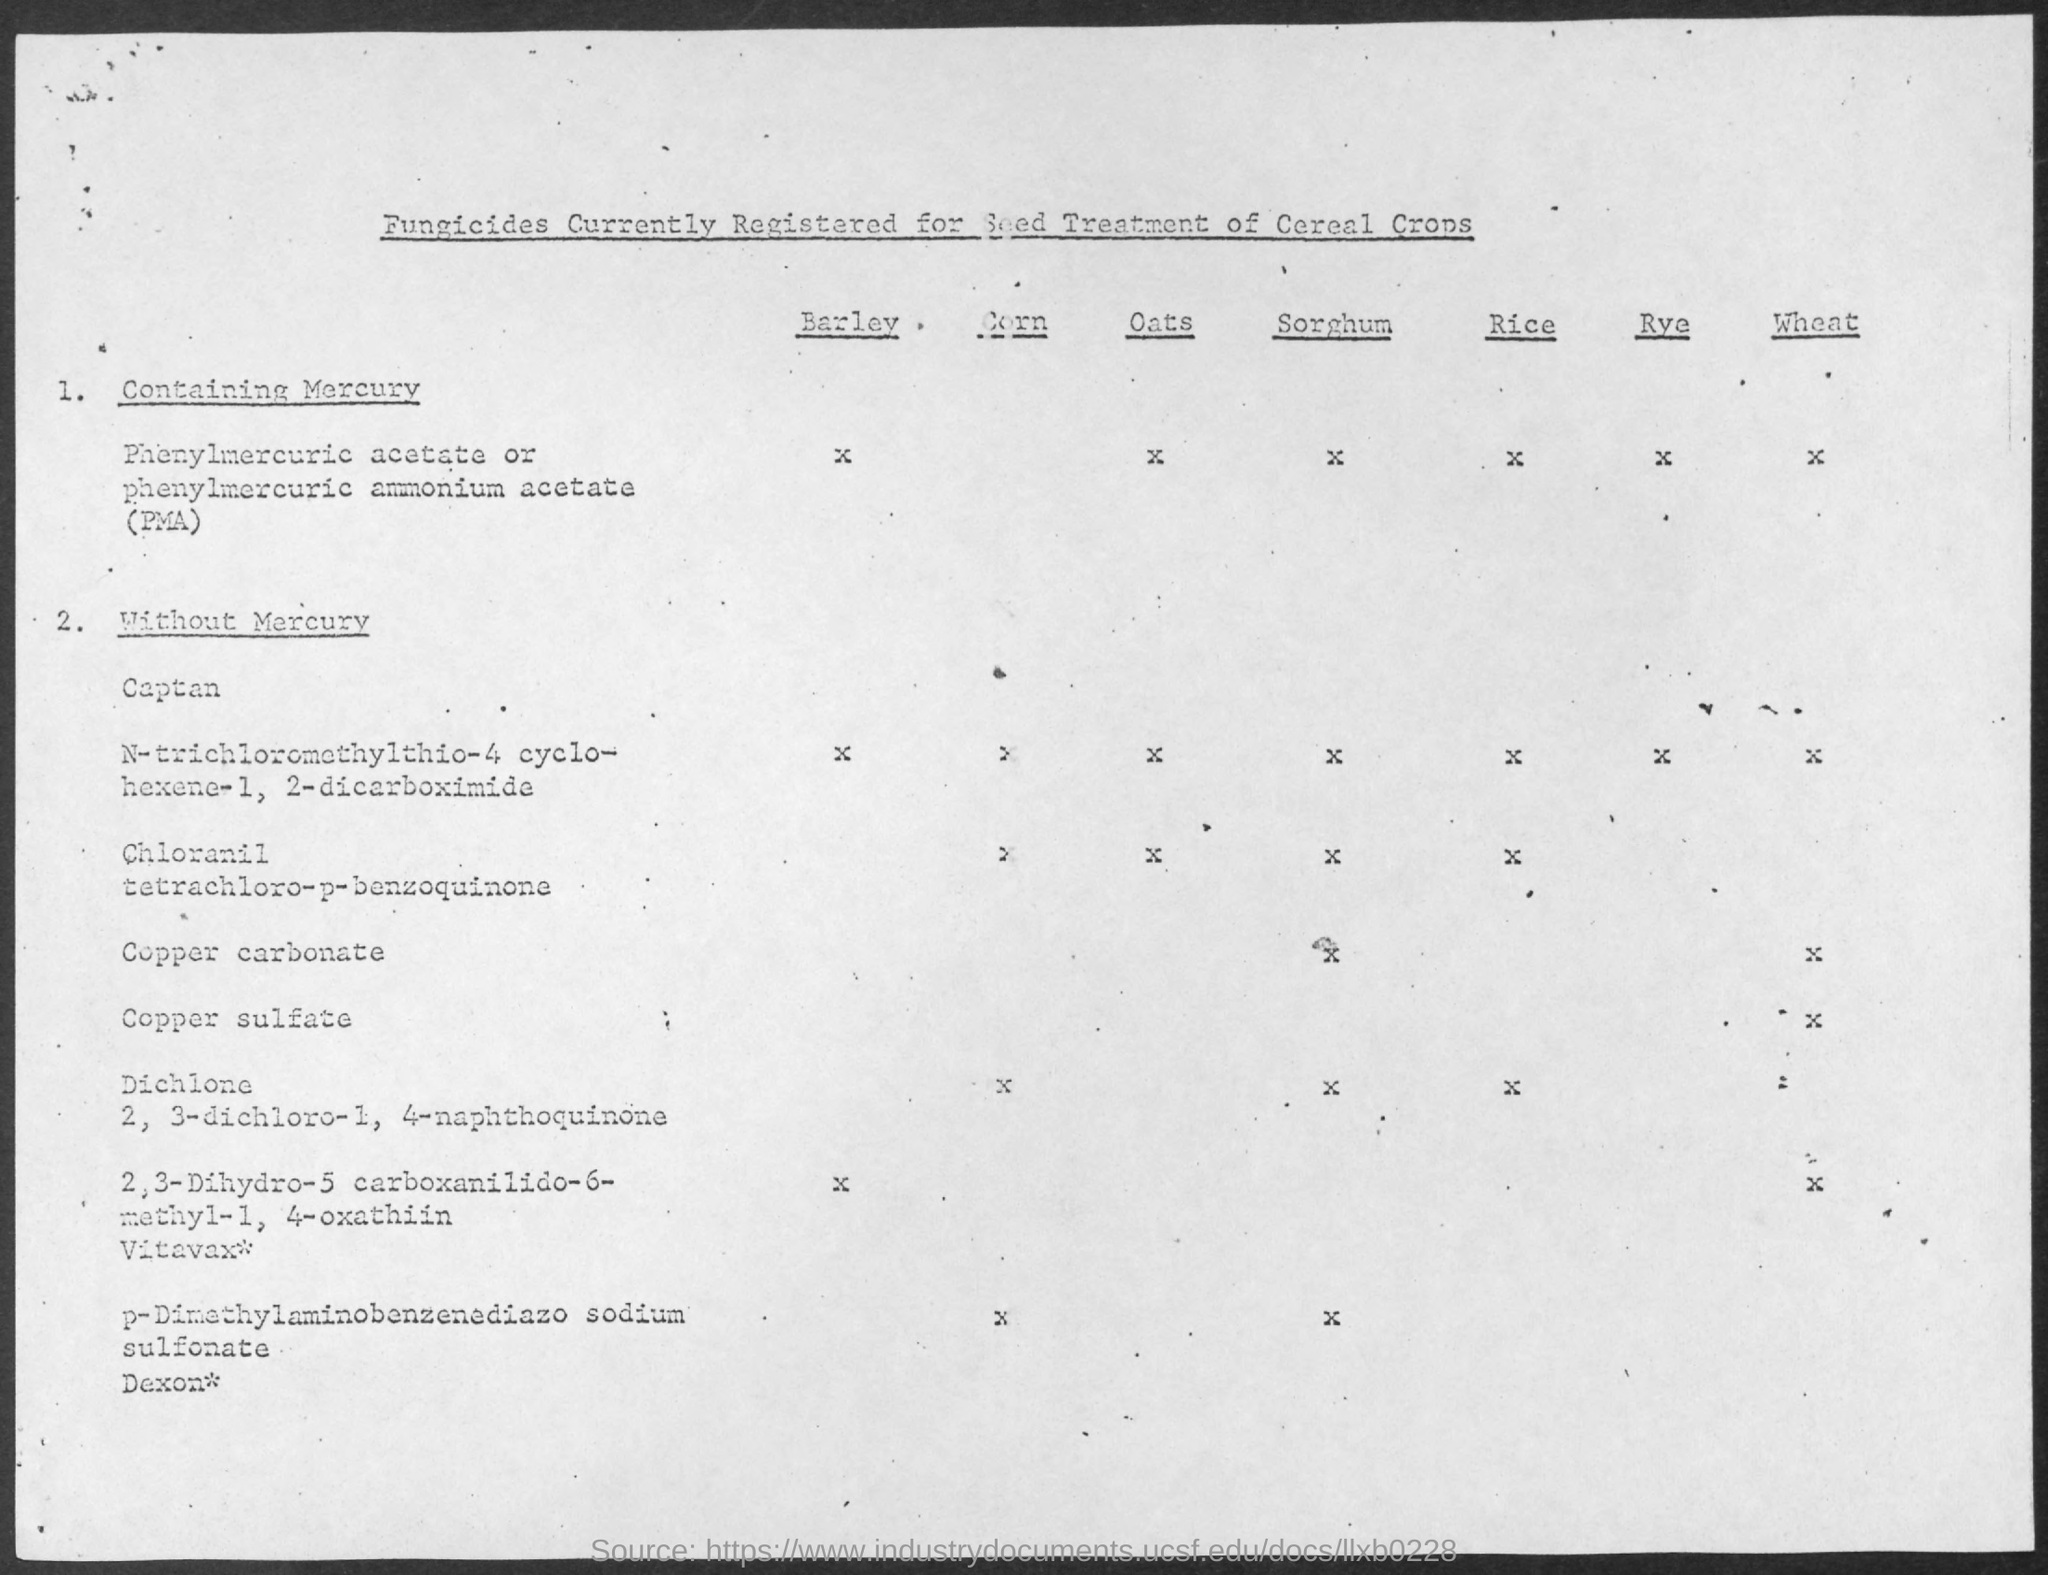What is the title of the document?
Offer a terse response. Fungicides Currently Registered for Seed Treatment of Cereal Crops. 